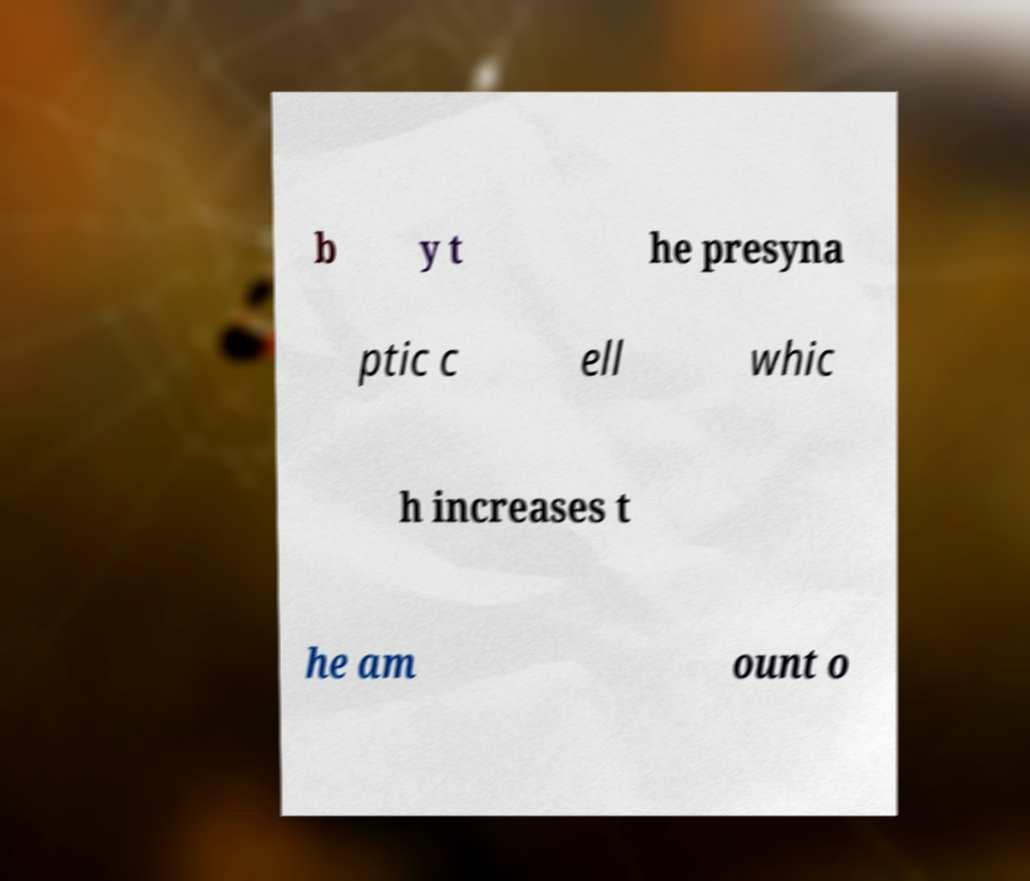Please read and relay the text visible in this image. What does it say? b y t he presyna ptic c ell whic h increases t he am ount o 